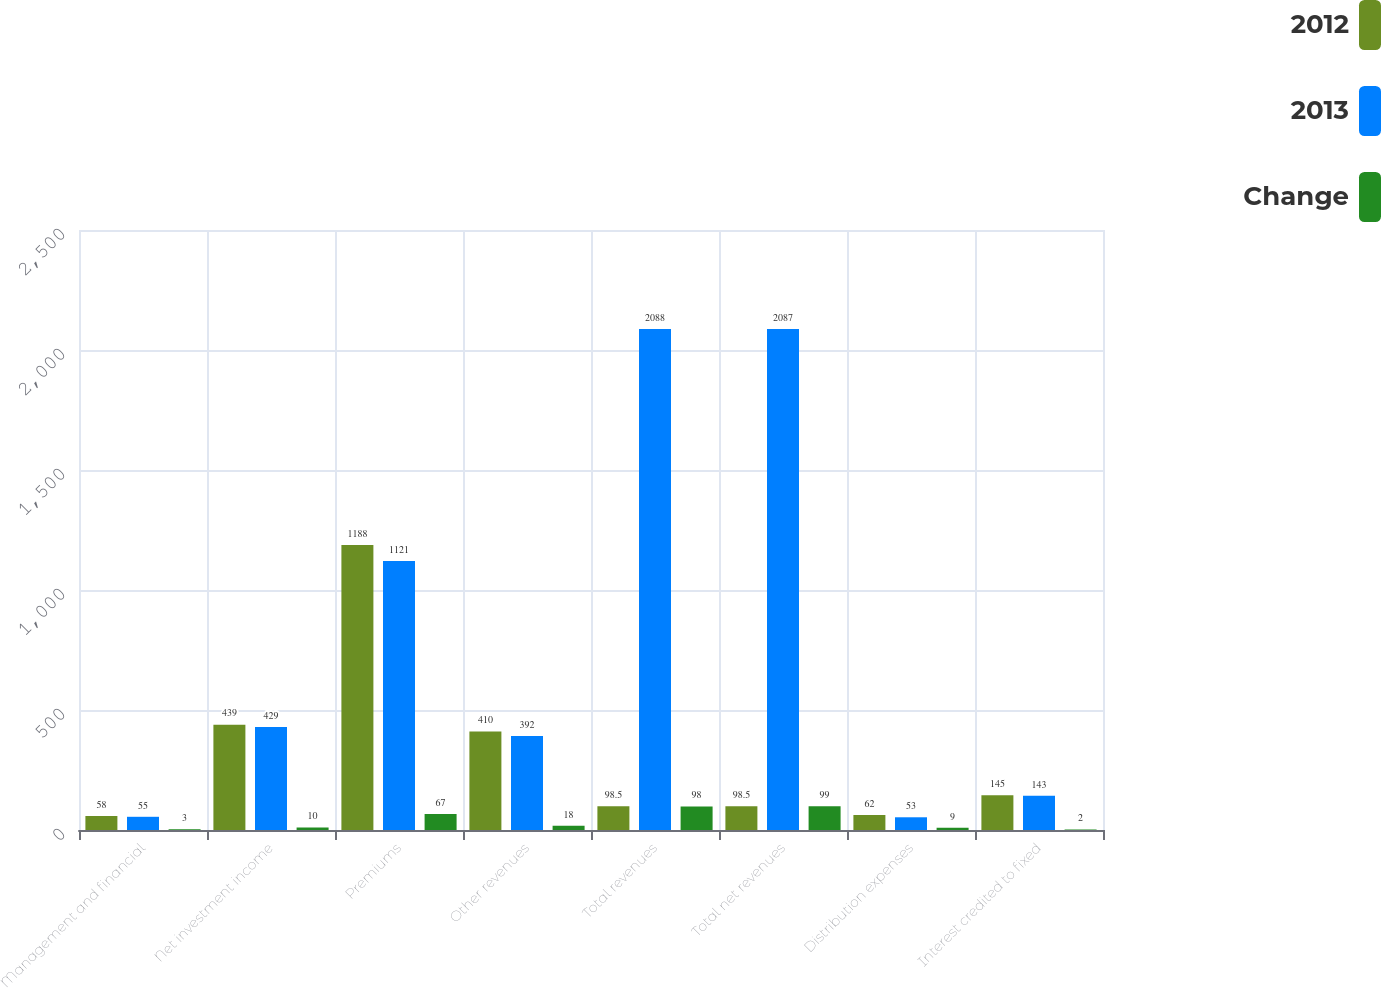Convert chart. <chart><loc_0><loc_0><loc_500><loc_500><stacked_bar_chart><ecel><fcel>Management and financial<fcel>Net investment income<fcel>Premiums<fcel>Other revenues<fcel>Total revenues<fcel>Total net revenues<fcel>Distribution expenses<fcel>Interest credited to fixed<nl><fcel>2012<fcel>58<fcel>439<fcel>1188<fcel>410<fcel>98.5<fcel>98.5<fcel>62<fcel>145<nl><fcel>2013<fcel>55<fcel>429<fcel>1121<fcel>392<fcel>2088<fcel>2087<fcel>53<fcel>143<nl><fcel>Change<fcel>3<fcel>10<fcel>67<fcel>18<fcel>98<fcel>99<fcel>9<fcel>2<nl></chart> 